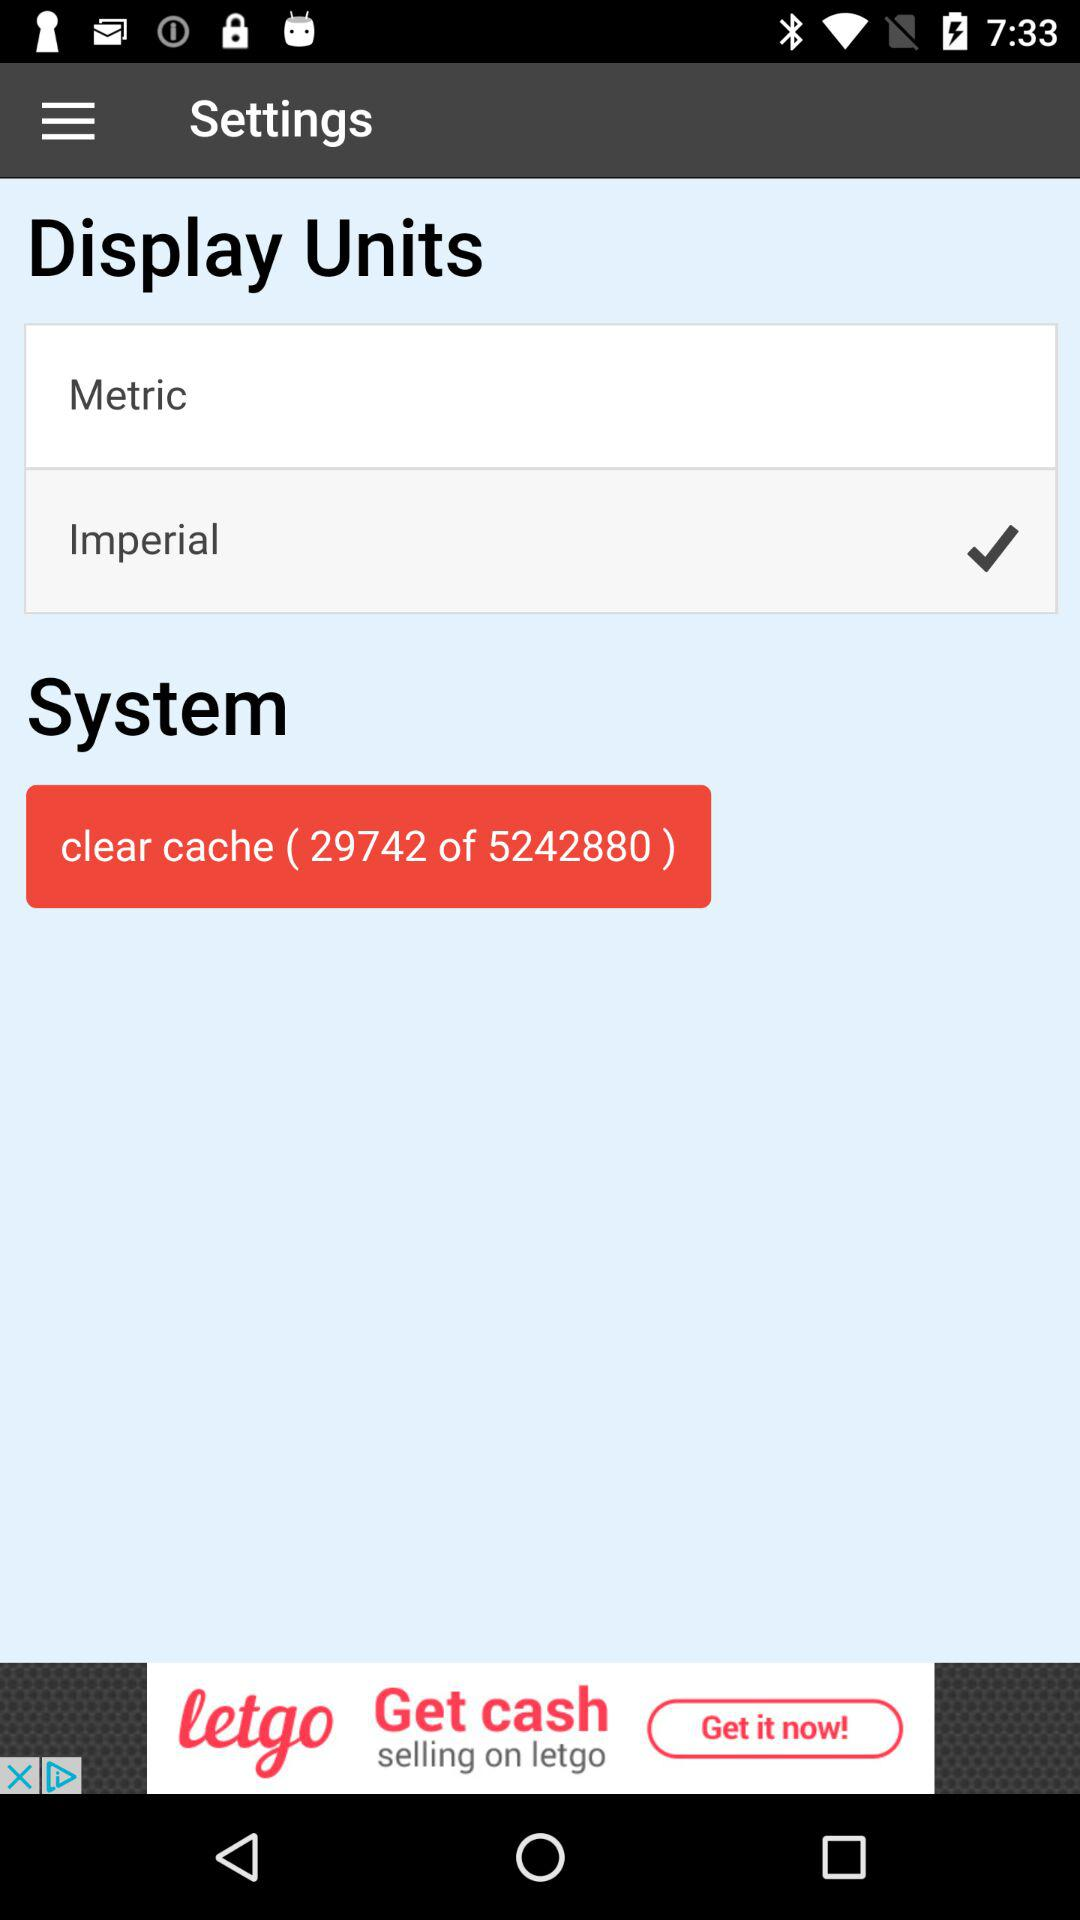How much cache needs to be cleared? The amount of cache that needs to be cleared is 29742. 